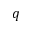Convert formula to latex. <formula><loc_0><loc_0><loc_500><loc_500>q</formula> 